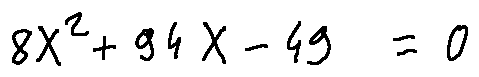Convert formula to latex. <formula><loc_0><loc_0><loc_500><loc_500>8 X ^ { 2 } + 9 4 X - 4 9 = 0</formula> 